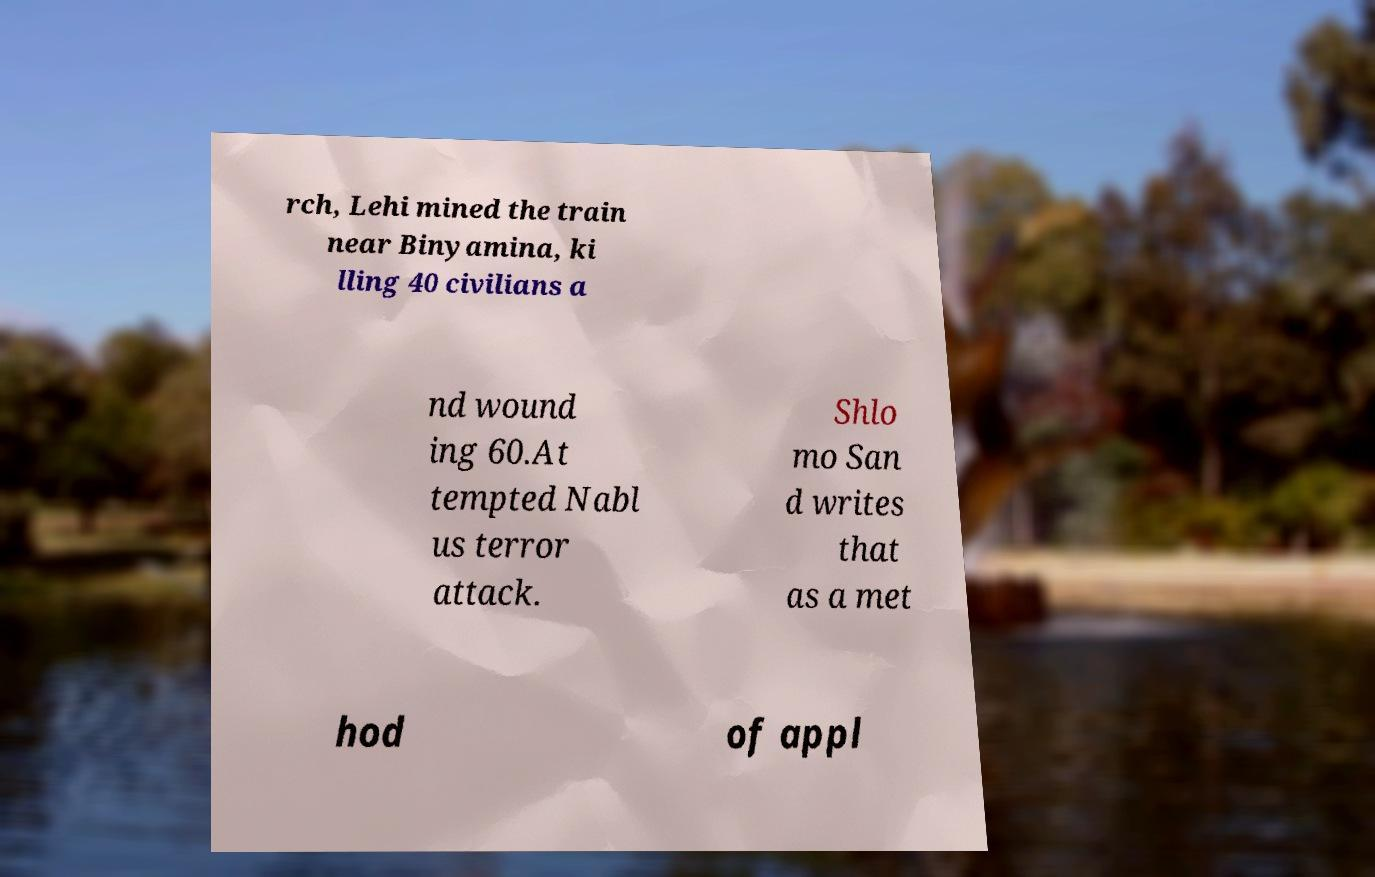I need the written content from this picture converted into text. Can you do that? rch, Lehi mined the train near Binyamina, ki lling 40 civilians a nd wound ing 60.At tempted Nabl us terror attack. Shlo mo San d writes that as a met hod of appl 